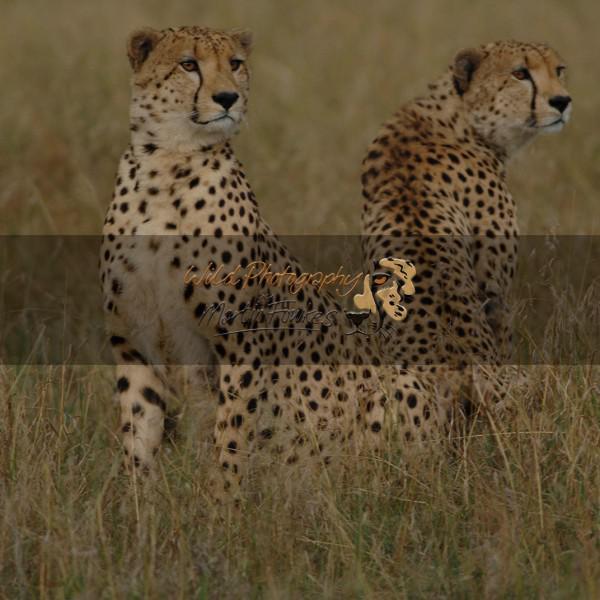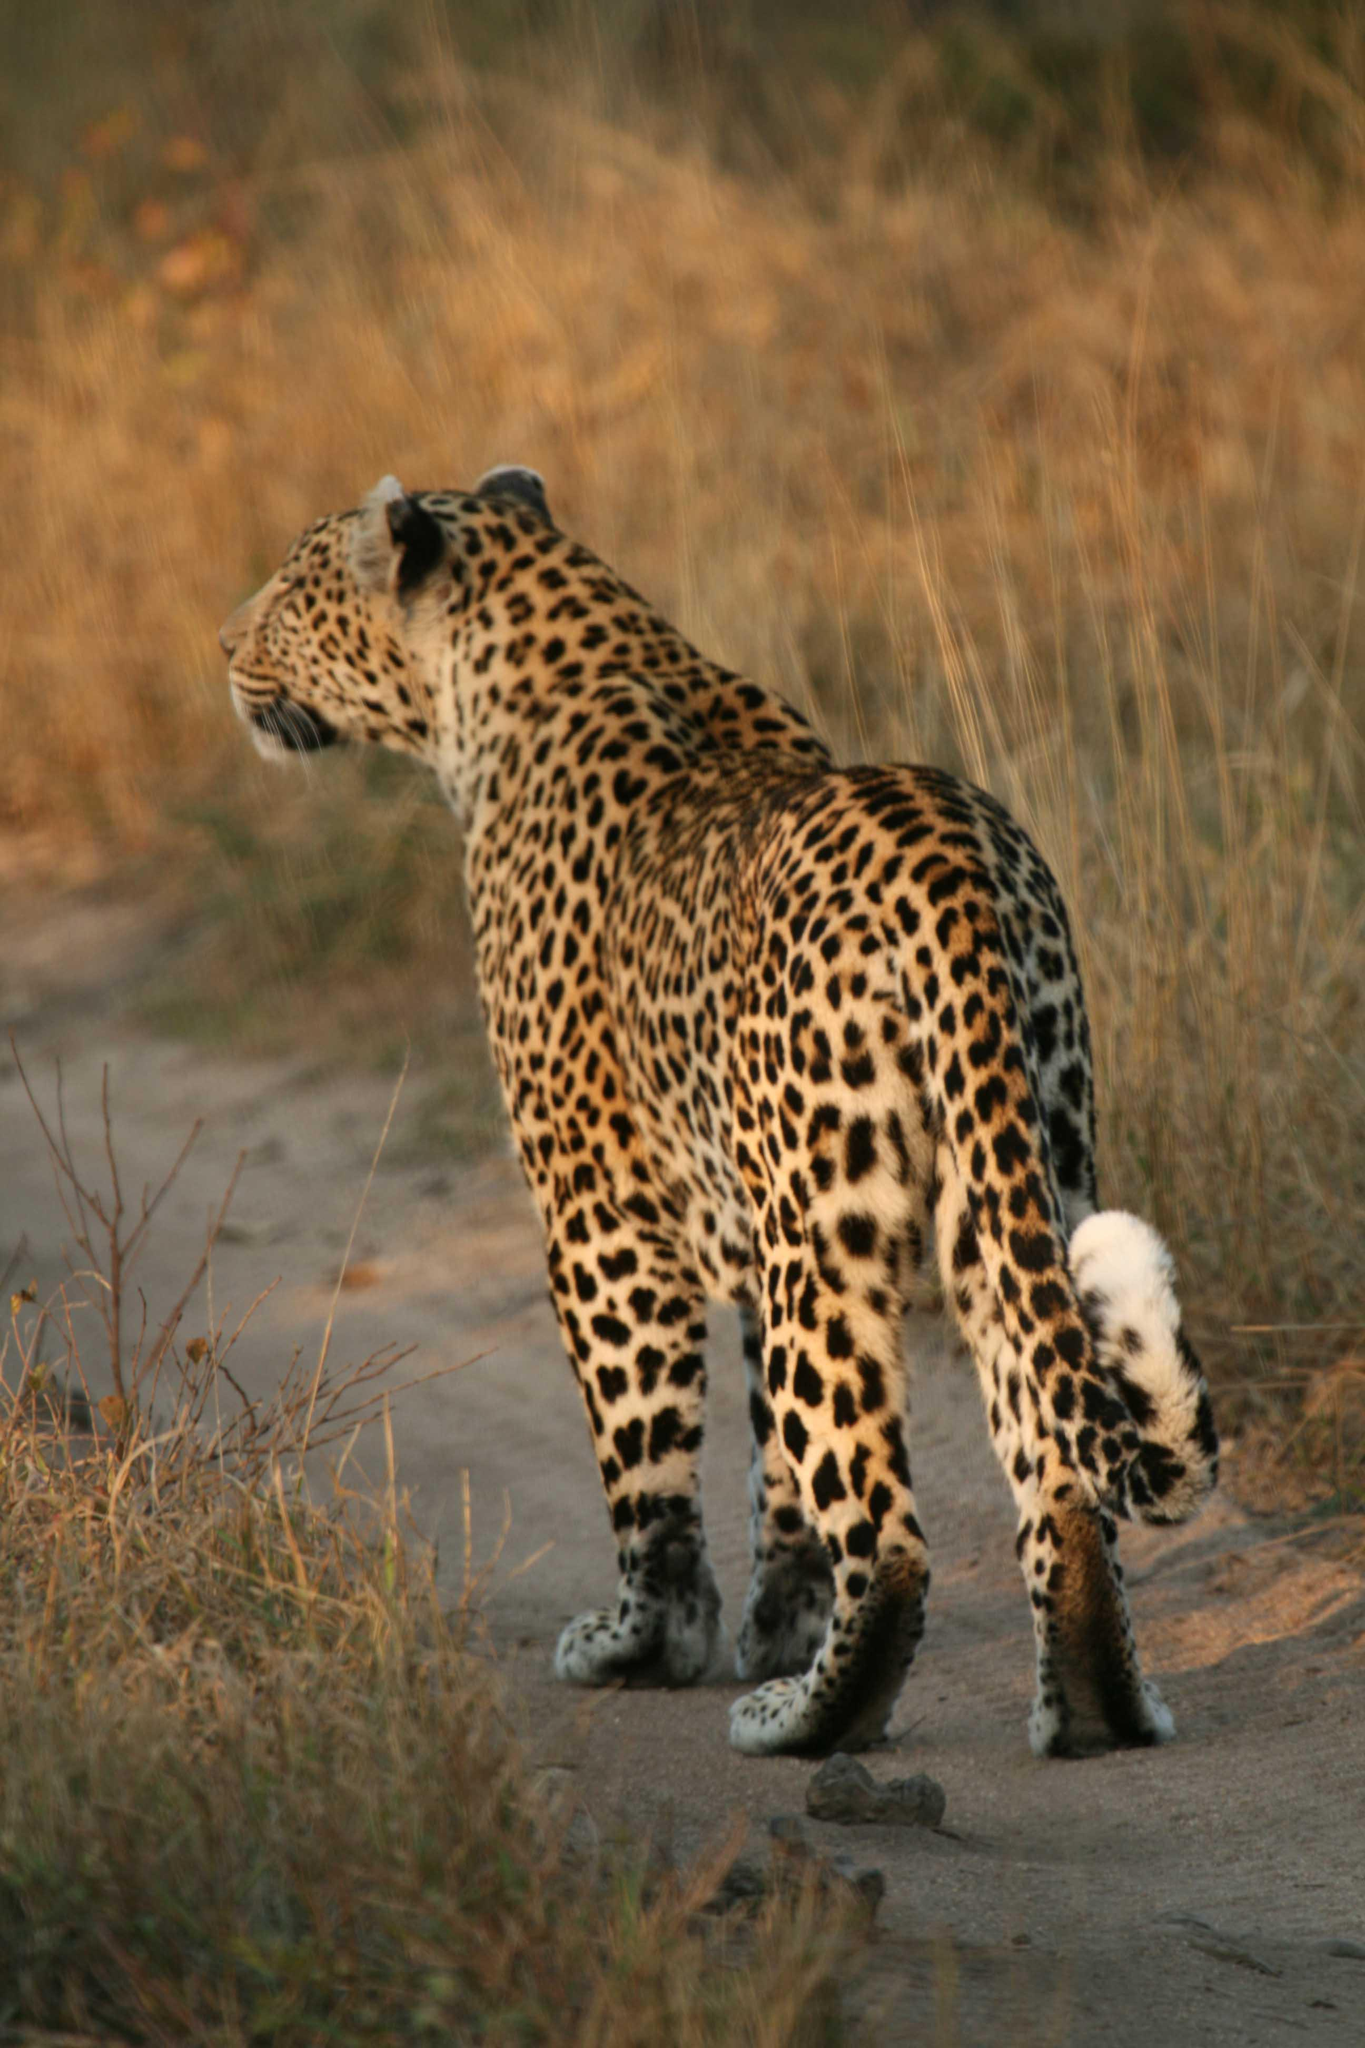The first image is the image on the left, the second image is the image on the right. Examine the images to the left and right. Is the description "In one of the images there is a single animal standing in a field." accurate? Answer yes or no. Yes. The first image is the image on the left, the second image is the image on the right. Analyze the images presented: Is the assertion "Each image contains exactly two cheetahs, and each image includes at least one reclining cheetah." valid? Answer yes or no. No. 